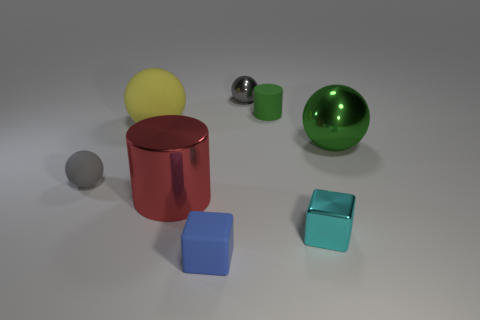Subtract all gray balls. How many were subtracted if there are1gray balls left? 1 Subtract all brown cubes. How many gray spheres are left? 2 Subtract 1 spheres. How many spheres are left? 3 Subtract all green spheres. How many spheres are left? 3 Subtract all yellow rubber balls. How many balls are left? 3 Add 2 tiny gray rubber spheres. How many objects exist? 10 Subtract all purple spheres. Subtract all cyan blocks. How many spheres are left? 4 Subtract all blocks. How many objects are left? 6 Subtract all small metal blocks. Subtract all large red metallic objects. How many objects are left? 6 Add 7 small gray rubber spheres. How many small gray rubber spheres are left? 8 